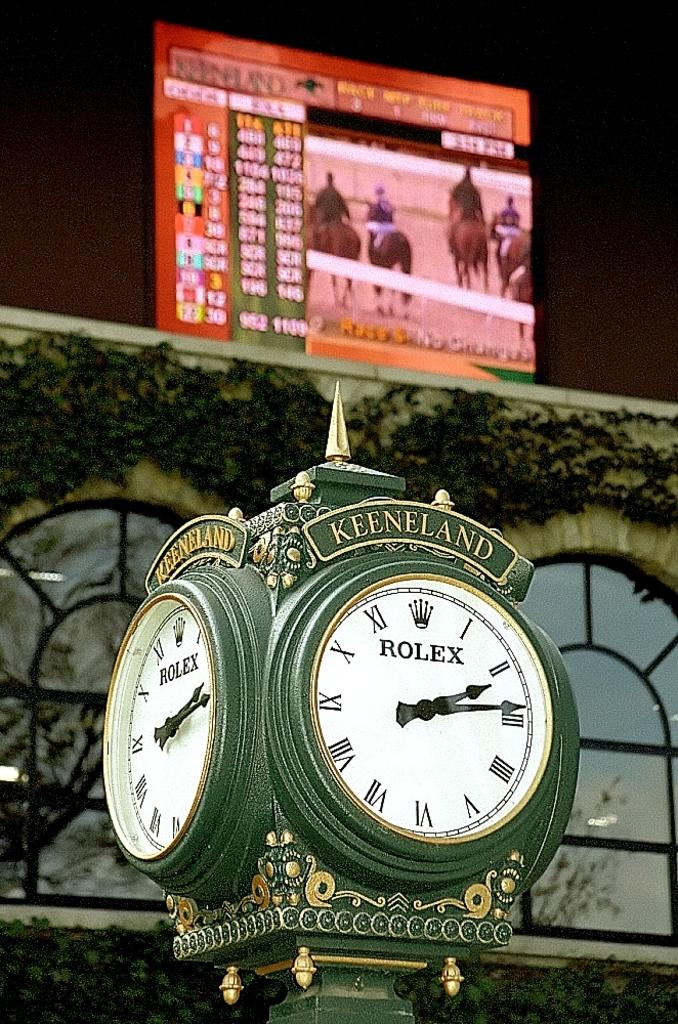<image>
Offer a succinct explanation of the picture presented. A rolex brand clock that says Keenland at the top. 